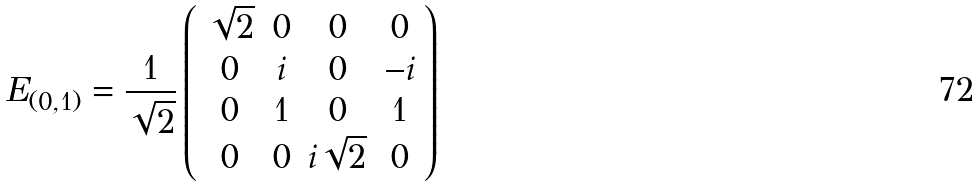<formula> <loc_0><loc_0><loc_500><loc_500>E _ { ( 0 , 1 ) } = \frac { 1 } { \sqrt { 2 } } \left ( \begin{array} { c c c c } \sqrt { 2 } & 0 & 0 & 0 \\ 0 & i & 0 & - i \\ 0 & 1 & 0 & 1 \\ 0 & 0 & i \sqrt { 2 } & 0 \end{array} \right )</formula> 